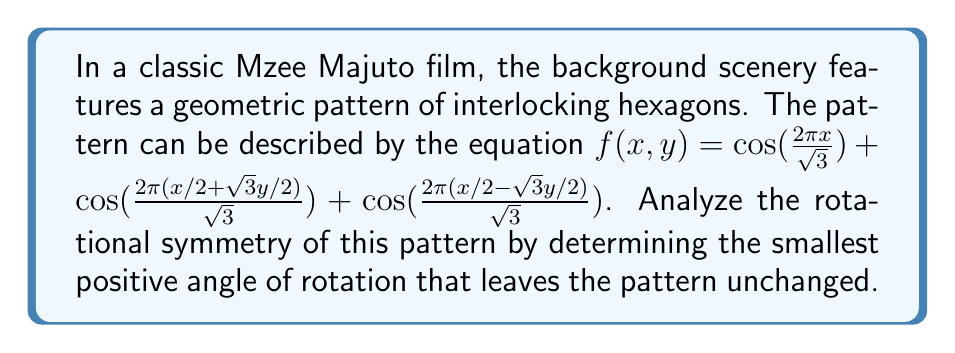Show me your answer to this math problem. To analyze the rotational symmetry of the hexagonal pattern, we need to follow these steps:

1) The hexagonal pattern is described by the function:
   $$f(x,y) = \cos(\frac{2\pi x}{\sqrt{3}}) + \cos(\frac{2\pi (x/2 + \sqrt{3}y/2)}{\sqrt{3}}) + \cos(\frac{2\pi (x/2 - \sqrt{3}y/2)}{\sqrt{3}})$$

2) This function represents a sum of three cosine waves, each rotated by 60° (or $\pi/3$ radians) relative to each other.

3) The rotational symmetry of a hexagon is 60°, meaning the pattern repeats every 60° rotation.

4) To verify this mathematically, we can use the rotation matrix:
   $$\begin{bmatrix} \cos\theta & -\sin\theta \\ \sin\theta & \cos\theta \end{bmatrix}$$

5) For a 60° rotation, $\theta = \pi/3$. Substituting this into the rotation matrix:
   $$\begin{bmatrix} \cos(\pi/3) & -\sin(\pi/3) \\ \sin(\pi/3) & \cos(\pi/3) \end{bmatrix} = \begin{bmatrix} 1/2 & -\sqrt{3}/2 \\ \sqrt{3}/2 & 1/2 \end{bmatrix}$$

6) Applying this rotation to $(x,y)$:
   $$\begin{bmatrix} x' \\ y' \end{bmatrix} = \begin{bmatrix} 1/2 & -\sqrt{3}/2 \\ \sqrt{3}/2 & 1/2 \end{bmatrix} \begin{bmatrix} x \\ y \end{bmatrix} = \begin{bmatrix} x/2 - \sqrt{3}y/2 \\ \sqrt{3}x/2 + y/2 \end{bmatrix}$$

7) Substituting these rotated coordinates into the original function:
   $$f(x',y') = \cos(\frac{2\pi (x/2 - \sqrt{3}y/2)}{\sqrt{3}}) + \cos(\frac{2\pi ((x/2 - \sqrt{3}y/2)/2 + \sqrt{3}(\sqrt{3}x/2 + y/2)/2)}{\sqrt{3}}) + \cos(\frac{2\pi ((x/2 - \sqrt{3}y/2)/2 - \sqrt{3}(\sqrt{3}x/2 + y/2)/2)}{\sqrt{3}})$$

8) Simplifying this expression, we get back the original function $f(x,y)$, confirming that the pattern is indeed unchanged by a 60° rotation.

Therefore, the smallest positive angle of rotation that leaves the pattern unchanged is 60° or $\pi/3$ radians.
Answer: 60° 